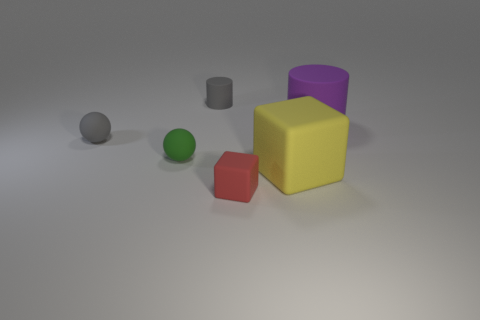Add 2 small red things. How many objects exist? 8 Subtract all cubes. How many objects are left? 4 Subtract all tiny red rubber cylinders. Subtract all red matte cubes. How many objects are left? 5 Add 4 small things. How many small things are left? 8 Add 6 blue metal cylinders. How many blue metal cylinders exist? 6 Subtract 0 blue cylinders. How many objects are left? 6 